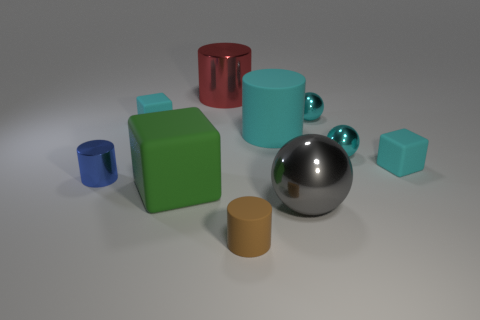What number of metallic balls are the same color as the large rubber cylinder?
Ensure brevity in your answer.  2. The red thing is what size?
Give a very brief answer. Large. There is a tiny brown matte object; what shape is it?
Provide a succinct answer. Cylinder. There is a tiny block on the right side of the big cyan cylinder; is it the same color as the large cube?
Your answer should be very brief. No. There is a blue metallic object that is the same shape as the red thing; what is its size?
Make the answer very short. Small. Are there any other things that are made of the same material as the small blue thing?
Provide a short and direct response. Yes. There is a cyan rubber thing that is on the right side of the metallic object in front of the tiny metal cylinder; are there any blue cylinders that are behind it?
Keep it short and to the point. No. What is the cylinder in front of the small metal cylinder made of?
Your response must be concise. Rubber. What number of big objects are either brown shiny things or red shiny cylinders?
Offer a very short reply. 1. There is a cyan block that is right of the gray shiny sphere; is its size the same as the gray ball?
Keep it short and to the point. No. 